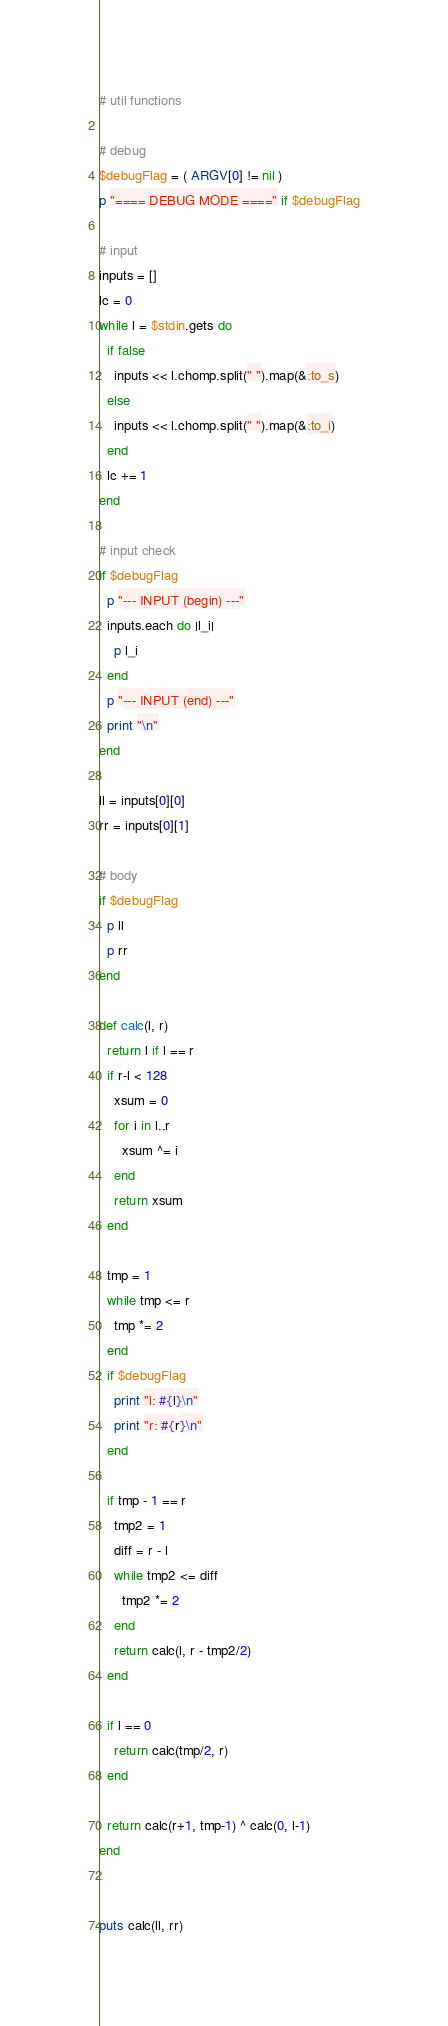<code> <loc_0><loc_0><loc_500><loc_500><_Ruby_># util functions

# debug
$debugFlag = ( ARGV[0] != nil )
p "==== DEBUG MODE ====" if $debugFlag

# input
inputs = []
lc = 0
while l = $stdin.gets do
  if false
    inputs << l.chomp.split(" ").map(&:to_s)
  else
    inputs << l.chomp.split(" ").map(&:to_i)
  end
  lc += 1
end

# input check
if $debugFlag
  p "--- INPUT (begin) ---"
  inputs.each do |l_i|
    p l_i
  end
  p "--- INPUT (end) ---"
  print "\n"
end

ll = inputs[0][0]
rr = inputs[0][1]

# body
if $debugFlag
  p ll
  p rr
end

def calc(l, r)
  return l if l == r
  if r-l < 128
    xsum = 0
    for i in l..r
      xsum ^= i
    end
    return xsum
  end
  
  tmp = 1
  while tmp <= r
    tmp *= 2
  end
  if $debugFlag
    print "l: #{l}\n"
    print "r: #{r}\n"
  end

  if tmp - 1 == r
    tmp2 = 1
    diff = r - l
    while tmp2 <= diff
      tmp2 *= 2
    end
    return calc(l, r - tmp2/2)
  end

  if l == 0
    return calc(tmp/2, r)
  end
  
  return calc(r+1, tmp-1) ^ calc(0, l-1)
end


puts calc(ll, rr)
</code> 